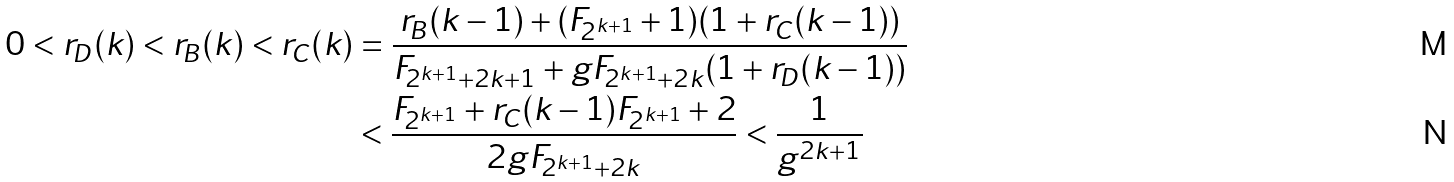Convert formula to latex. <formula><loc_0><loc_0><loc_500><loc_500>0 < r _ { D } ( k ) < r _ { B } ( k ) < r _ { C } ( k ) & = \frac { r _ { B } ( k - 1 ) + ( F _ { 2 ^ { k + 1 } } + 1 ) ( 1 + r _ { C } ( k - 1 ) ) } { F _ { 2 ^ { k + 1 } + 2 k + 1 } + g F _ { 2 ^ { k + 1 } + 2 k } ( 1 + r _ { D } ( k - 1 ) ) } \\ & < \frac { F _ { 2 ^ { k + 1 } } + r _ { C } ( k - 1 ) F _ { 2 ^ { k + 1 } } + 2 } { 2 g F _ { 2 ^ { k + 1 } + 2 k } } < \frac { 1 } { g ^ { 2 k + 1 } }</formula> 